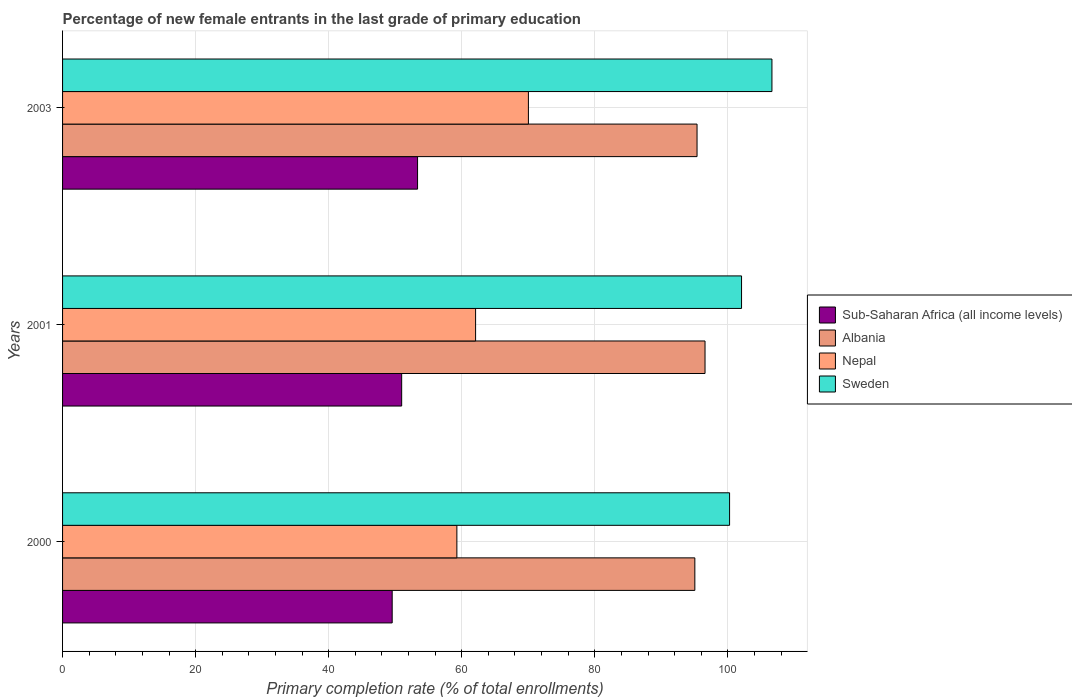How many groups of bars are there?
Make the answer very short. 3. How many bars are there on the 2nd tick from the bottom?
Keep it short and to the point. 4. What is the label of the 1st group of bars from the top?
Provide a short and direct response. 2003. What is the percentage of new female entrants in Sub-Saharan Africa (all income levels) in 2003?
Provide a succinct answer. 53.36. Across all years, what is the maximum percentage of new female entrants in Sub-Saharan Africa (all income levels)?
Your answer should be very brief. 53.36. Across all years, what is the minimum percentage of new female entrants in Nepal?
Keep it short and to the point. 59.27. In which year was the percentage of new female entrants in Nepal maximum?
Offer a very short reply. 2003. In which year was the percentage of new female entrants in Nepal minimum?
Your answer should be compact. 2000. What is the total percentage of new female entrants in Nepal in the graph?
Offer a terse response. 191.37. What is the difference between the percentage of new female entrants in Nepal in 2001 and that in 2003?
Give a very brief answer. -7.94. What is the difference between the percentage of new female entrants in Albania in 2001 and the percentage of new female entrants in Sub-Saharan Africa (all income levels) in 2003?
Offer a terse response. 43.21. What is the average percentage of new female entrants in Sweden per year?
Give a very brief answer. 102.98. In the year 2003, what is the difference between the percentage of new female entrants in Sub-Saharan Africa (all income levels) and percentage of new female entrants in Albania?
Offer a terse response. -42.01. In how many years, is the percentage of new female entrants in Sweden greater than 12 %?
Provide a succinct answer. 3. What is the ratio of the percentage of new female entrants in Sweden in 2000 to that in 2001?
Your answer should be very brief. 0.98. Is the difference between the percentage of new female entrants in Sub-Saharan Africa (all income levels) in 2000 and 2003 greater than the difference between the percentage of new female entrants in Albania in 2000 and 2003?
Keep it short and to the point. No. What is the difference between the highest and the second highest percentage of new female entrants in Albania?
Your answer should be compact. 1.2. What is the difference between the highest and the lowest percentage of new female entrants in Albania?
Your answer should be very brief. 1.53. What does the 2nd bar from the top in 2000 represents?
Your response must be concise. Nepal. What does the 1st bar from the bottom in 2001 represents?
Provide a succinct answer. Sub-Saharan Africa (all income levels). Is it the case that in every year, the sum of the percentage of new female entrants in Nepal and percentage of new female entrants in Albania is greater than the percentage of new female entrants in Sub-Saharan Africa (all income levels)?
Your response must be concise. Yes. Are all the bars in the graph horizontal?
Your response must be concise. Yes. What is the difference between two consecutive major ticks on the X-axis?
Provide a short and direct response. 20. Does the graph contain any zero values?
Provide a succinct answer. No. How many legend labels are there?
Provide a short and direct response. 4. What is the title of the graph?
Offer a very short reply. Percentage of new female entrants in the last grade of primary education. Does "Montenegro" appear as one of the legend labels in the graph?
Offer a terse response. No. What is the label or title of the X-axis?
Offer a very short reply. Primary completion rate (% of total enrollments). What is the label or title of the Y-axis?
Give a very brief answer. Years. What is the Primary completion rate (% of total enrollments) in Sub-Saharan Africa (all income levels) in 2000?
Provide a short and direct response. 49.55. What is the Primary completion rate (% of total enrollments) in Albania in 2000?
Provide a short and direct response. 95.04. What is the Primary completion rate (% of total enrollments) of Nepal in 2000?
Offer a terse response. 59.27. What is the Primary completion rate (% of total enrollments) in Sweden in 2000?
Your answer should be compact. 100.26. What is the Primary completion rate (% of total enrollments) in Sub-Saharan Africa (all income levels) in 2001?
Offer a terse response. 50.97. What is the Primary completion rate (% of total enrollments) of Albania in 2001?
Ensure brevity in your answer.  96.57. What is the Primary completion rate (% of total enrollments) in Nepal in 2001?
Provide a short and direct response. 62.08. What is the Primary completion rate (% of total enrollments) in Sweden in 2001?
Provide a succinct answer. 102.06. What is the Primary completion rate (% of total enrollments) of Sub-Saharan Africa (all income levels) in 2003?
Your answer should be very brief. 53.36. What is the Primary completion rate (% of total enrollments) in Albania in 2003?
Ensure brevity in your answer.  95.37. What is the Primary completion rate (% of total enrollments) of Nepal in 2003?
Keep it short and to the point. 70.02. What is the Primary completion rate (% of total enrollments) in Sweden in 2003?
Keep it short and to the point. 106.63. Across all years, what is the maximum Primary completion rate (% of total enrollments) in Sub-Saharan Africa (all income levels)?
Provide a succinct answer. 53.36. Across all years, what is the maximum Primary completion rate (% of total enrollments) of Albania?
Your answer should be compact. 96.57. Across all years, what is the maximum Primary completion rate (% of total enrollments) in Nepal?
Offer a very short reply. 70.02. Across all years, what is the maximum Primary completion rate (% of total enrollments) of Sweden?
Your answer should be compact. 106.63. Across all years, what is the minimum Primary completion rate (% of total enrollments) of Sub-Saharan Africa (all income levels)?
Your answer should be compact. 49.55. Across all years, what is the minimum Primary completion rate (% of total enrollments) of Albania?
Offer a very short reply. 95.04. Across all years, what is the minimum Primary completion rate (% of total enrollments) of Nepal?
Ensure brevity in your answer.  59.27. Across all years, what is the minimum Primary completion rate (% of total enrollments) of Sweden?
Keep it short and to the point. 100.26. What is the total Primary completion rate (% of total enrollments) in Sub-Saharan Africa (all income levels) in the graph?
Offer a very short reply. 153.88. What is the total Primary completion rate (% of total enrollments) of Albania in the graph?
Ensure brevity in your answer.  286.98. What is the total Primary completion rate (% of total enrollments) of Nepal in the graph?
Give a very brief answer. 191.37. What is the total Primary completion rate (% of total enrollments) of Sweden in the graph?
Your answer should be very brief. 308.94. What is the difference between the Primary completion rate (% of total enrollments) of Sub-Saharan Africa (all income levels) in 2000 and that in 2001?
Your answer should be very brief. -1.43. What is the difference between the Primary completion rate (% of total enrollments) of Albania in 2000 and that in 2001?
Your response must be concise. -1.53. What is the difference between the Primary completion rate (% of total enrollments) in Nepal in 2000 and that in 2001?
Offer a very short reply. -2.81. What is the difference between the Primary completion rate (% of total enrollments) of Sweden in 2000 and that in 2001?
Your answer should be very brief. -1.8. What is the difference between the Primary completion rate (% of total enrollments) in Sub-Saharan Africa (all income levels) in 2000 and that in 2003?
Provide a short and direct response. -3.81. What is the difference between the Primary completion rate (% of total enrollments) of Albania in 2000 and that in 2003?
Offer a very short reply. -0.33. What is the difference between the Primary completion rate (% of total enrollments) of Nepal in 2000 and that in 2003?
Keep it short and to the point. -10.75. What is the difference between the Primary completion rate (% of total enrollments) of Sweden in 2000 and that in 2003?
Ensure brevity in your answer.  -6.37. What is the difference between the Primary completion rate (% of total enrollments) of Sub-Saharan Africa (all income levels) in 2001 and that in 2003?
Provide a short and direct response. -2.39. What is the difference between the Primary completion rate (% of total enrollments) of Albania in 2001 and that in 2003?
Make the answer very short. 1.2. What is the difference between the Primary completion rate (% of total enrollments) of Nepal in 2001 and that in 2003?
Provide a succinct answer. -7.94. What is the difference between the Primary completion rate (% of total enrollments) of Sweden in 2001 and that in 2003?
Offer a terse response. -4.57. What is the difference between the Primary completion rate (% of total enrollments) of Sub-Saharan Africa (all income levels) in 2000 and the Primary completion rate (% of total enrollments) of Albania in 2001?
Your response must be concise. -47.02. What is the difference between the Primary completion rate (% of total enrollments) of Sub-Saharan Africa (all income levels) in 2000 and the Primary completion rate (% of total enrollments) of Nepal in 2001?
Your answer should be very brief. -12.54. What is the difference between the Primary completion rate (% of total enrollments) of Sub-Saharan Africa (all income levels) in 2000 and the Primary completion rate (% of total enrollments) of Sweden in 2001?
Offer a terse response. -52.51. What is the difference between the Primary completion rate (% of total enrollments) in Albania in 2000 and the Primary completion rate (% of total enrollments) in Nepal in 2001?
Offer a very short reply. 32.96. What is the difference between the Primary completion rate (% of total enrollments) of Albania in 2000 and the Primary completion rate (% of total enrollments) of Sweden in 2001?
Keep it short and to the point. -7.02. What is the difference between the Primary completion rate (% of total enrollments) of Nepal in 2000 and the Primary completion rate (% of total enrollments) of Sweden in 2001?
Provide a succinct answer. -42.79. What is the difference between the Primary completion rate (% of total enrollments) of Sub-Saharan Africa (all income levels) in 2000 and the Primary completion rate (% of total enrollments) of Albania in 2003?
Your response must be concise. -45.82. What is the difference between the Primary completion rate (% of total enrollments) of Sub-Saharan Africa (all income levels) in 2000 and the Primary completion rate (% of total enrollments) of Nepal in 2003?
Your answer should be compact. -20.47. What is the difference between the Primary completion rate (% of total enrollments) of Sub-Saharan Africa (all income levels) in 2000 and the Primary completion rate (% of total enrollments) of Sweden in 2003?
Keep it short and to the point. -57.08. What is the difference between the Primary completion rate (% of total enrollments) in Albania in 2000 and the Primary completion rate (% of total enrollments) in Nepal in 2003?
Offer a terse response. 25.02. What is the difference between the Primary completion rate (% of total enrollments) in Albania in 2000 and the Primary completion rate (% of total enrollments) in Sweden in 2003?
Offer a terse response. -11.59. What is the difference between the Primary completion rate (% of total enrollments) of Nepal in 2000 and the Primary completion rate (% of total enrollments) of Sweden in 2003?
Give a very brief answer. -47.36. What is the difference between the Primary completion rate (% of total enrollments) of Sub-Saharan Africa (all income levels) in 2001 and the Primary completion rate (% of total enrollments) of Albania in 2003?
Provide a succinct answer. -44.4. What is the difference between the Primary completion rate (% of total enrollments) in Sub-Saharan Africa (all income levels) in 2001 and the Primary completion rate (% of total enrollments) in Nepal in 2003?
Give a very brief answer. -19.05. What is the difference between the Primary completion rate (% of total enrollments) in Sub-Saharan Africa (all income levels) in 2001 and the Primary completion rate (% of total enrollments) in Sweden in 2003?
Make the answer very short. -55.66. What is the difference between the Primary completion rate (% of total enrollments) in Albania in 2001 and the Primary completion rate (% of total enrollments) in Nepal in 2003?
Your answer should be compact. 26.55. What is the difference between the Primary completion rate (% of total enrollments) in Albania in 2001 and the Primary completion rate (% of total enrollments) in Sweden in 2003?
Offer a very short reply. -10.06. What is the difference between the Primary completion rate (% of total enrollments) of Nepal in 2001 and the Primary completion rate (% of total enrollments) of Sweden in 2003?
Give a very brief answer. -44.55. What is the average Primary completion rate (% of total enrollments) in Sub-Saharan Africa (all income levels) per year?
Ensure brevity in your answer.  51.29. What is the average Primary completion rate (% of total enrollments) of Albania per year?
Provide a short and direct response. 95.66. What is the average Primary completion rate (% of total enrollments) in Nepal per year?
Your answer should be very brief. 63.79. What is the average Primary completion rate (% of total enrollments) in Sweden per year?
Make the answer very short. 102.98. In the year 2000, what is the difference between the Primary completion rate (% of total enrollments) of Sub-Saharan Africa (all income levels) and Primary completion rate (% of total enrollments) of Albania?
Your answer should be very brief. -45.49. In the year 2000, what is the difference between the Primary completion rate (% of total enrollments) of Sub-Saharan Africa (all income levels) and Primary completion rate (% of total enrollments) of Nepal?
Your response must be concise. -9.72. In the year 2000, what is the difference between the Primary completion rate (% of total enrollments) in Sub-Saharan Africa (all income levels) and Primary completion rate (% of total enrollments) in Sweden?
Your answer should be compact. -50.71. In the year 2000, what is the difference between the Primary completion rate (% of total enrollments) of Albania and Primary completion rate (% of total enrollments) of Nepal?
Keep it short and to the point. 35.77. In the year 2000, what is the difference between the Primary completion rate (% of total enrollments) of Albania and Primary completion rate (% of total enrollments) of Sweden?
Provide a short and direct response. -5.22. In the year 2000, what is the difference between the Primary completion rate (% of total enrollments) in Nepal and Primary completion rate (% of total enrollments) in Sweden?
Provide a short and direct response. -40.99. In the year 2001, what is the difference between the Primary completion rate (% of total enrollments) of Sub-Saharan Africa (all income levels) and Primary completion rate (% of total enrollments) of Albania?
Keep it short and to the point. -45.6. In the year 2001, what is the difference between the Primary completion rate (% of total enrollments) of Sub-Saharan Africa (all income levels) and Primary completion rate (% of total enrollments) of Nepal?
Your answer should be compact. -11.11. In the year 2001, what is the difference between the Primary completion rate (% of total enrollments) in Sub-Saharan Africa (all income levels) and Primary completion rate (% of total enrollments) in Sweden?
Provide a succinct answer. -51.09. In the year 2001, what is the difference between the Primary completion rate (% of total enrollments) of Albania and Primary completion rate (% of total enrollments) of Nepal?
Provide a succinct answer. 34.49. In the year 2001, what is the difference between the Primary completion rate (% of total enrollments) of Albania and Primary completion rate (% of total enrollments) of Sweden?
Provide a succinct answer. -5.49. In the year 2001, what is the difference between the Primary completion rate (% of total enrollments) of Nepal and Primary completion rate (% of total enrollments) of Sweden?
Give a very brief answer. -39.98. In the year 2003, what is the difference between the Primary completion rate (% of total enrollments) in Sub-Saharan Africa (all income levels) and Primary completion rate (% of total enrollments) in Albania?
Your answer should be very brief. -42.01. In the year 2003, what is the difference between the Primary completion rate (% of total enrollments) of Sub-Saharan Africa (all income levels) and Primary completion rate (% of total enrollments) of Nepal?
Ensure brevity in your answer.  -16.66. In the year 2003, what is the difference between the Primary completion rate (% of total enrollments) in Sub-Saharan Africa (all income levels) and Primary completion rate (% of total enrollments) in Sweden?
Make the answer very short. -53.27. In the year 2003, what is the difference between the Primary completion rate (% of total enrollments) in Albania and Primary completion rate (% of total enrollments) in Nepal?
Your answer should be very brief. 25.35. In the year 2003, what is the difference between the Primary completion rate (% of total enrollments) in Albania and Primary completion rate (% of total enrollments) in Sweden?
Offer a terse response. -11.26. In the year 2003, what is the difference between the Primary completion rate (% of total enrollments) in Nepal and Primary completion rate (% of total enrollments) in Sweden?
Your response must be concise. -36.61. What is the ratio of the Primary completion rate (% of total enrollments) of Sub-Saharan Africa (all income levels) in 2000 to that in 2001?
Give a very brief answer. 0.97. What is the ratio of the Primary completion rate (% of total enrollments) in Albania in 2000 to that in 2001?
Make the answer very short. 0.98. What is the ratio of the Primary completion rate (% of total enrollments) in Nepal in 2000 to that in 2001?
Your response must be concise. 0.95. What is the ratio of the Primary completion rate (% of total enrollments) of Sweden in 2000 to that in 2001?
Your response must be concise. 0.98. What is the ratio of the Primary completion rate (% of total enrollments) in Sub-Saharan Africa (all income levels) in 2000 to that in 2003?
Provide a succinct answer. 0.93. What is the ratio of the Primary completion rate (% of total enrollments) in Albania in 2000 to that in 2003?
Offer a very short reply. 1. What is the ratio of the Primary completion rate (% of total enrollments) of Nepal in 2000 to that in 2003?
Make the answer very short. 0.85. What is the ratio of the Primary completion rate (% of total enrollments) in Sweden in 2000 to that in 2003?
Your answer should be very brief. 0.94. What is the ratio of the Primary completion rate (% of total enrollments) of Sub-Saharan Africa (all income levels) in 2001 to that in 2003?
Ensure brevity in your answer.  0.96. What is the ratio of the Primary completion rate (% of total enrollments) of Albania in 2001 to that in 2003?
Offer a very short reply. 1.01. What is the ratio of the Primary completion rate (% of total enrollments) of Nepal in 2001 to that in 2003?
Provide a short and direct response. 0.89. What is the ratio of the Primary completion rate (% of total enrollments) of Sweden in 2001 to that in 2003?
Ensure brevity in your answer.  0.96. What is the difference between the highest and the second highest Primary completion rate (% of total enrollments) of Sub-Saharan Africa (all income levels)?
Provide a succinct answer. 2.39. What is the difference between the highest and the second highest Primary completion rate (% of total enrollments) of Albania?
Offer a very short reply. 1.2. What is the difference between the highest and the second highest Primary completion rate (% of total enrollments) of Nepal?
Offer a terse response. 7.94. What is the difference between the highest and the second highest Primary completion rate (% of total enrollments) of Sweden?
Offer a terse response. 4.57. What is the difference between the highest and the lowest Primary completion rate (% of total enrollments) in Sub-Saharan Africa (all income levels)?
Your answer should be compact. 3.81. What is the difference between the highest and the lowest Primary completion rate (% of total enrollments) in Albania?
Your response must be concise. 1.53. What is the difference between the highest and the lowest Primary completion rate (% of total enrollments) of Nepal?
Offer a very short reply. 10.75. What is the difference between the highest and the lowest Primary completion rate (% of total enrollments) of Sweden?
Make the answer very short. 6.37. 